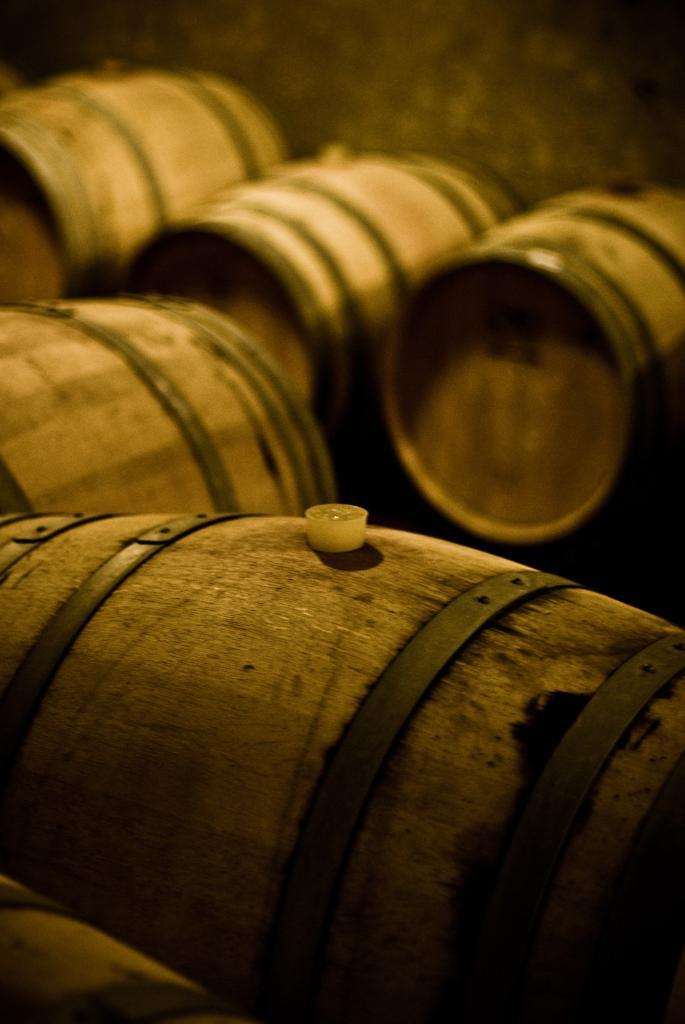What type of containers are present in the image? There are wooden barrels in the image. What is the color of the wooden barrels? The wooden barrels are brown in color. Is there any indication of the barrels being sealed or closed? Yes, there is a cork on one of the barrels. Can you describe the background of the image? The background of the image is blurry. How many yaks are visible in the image? There are no yaks present in the image. What is the mass of the wooden barrels in the image? The mass of the wooden barrels cannot be determined from the image alone. 